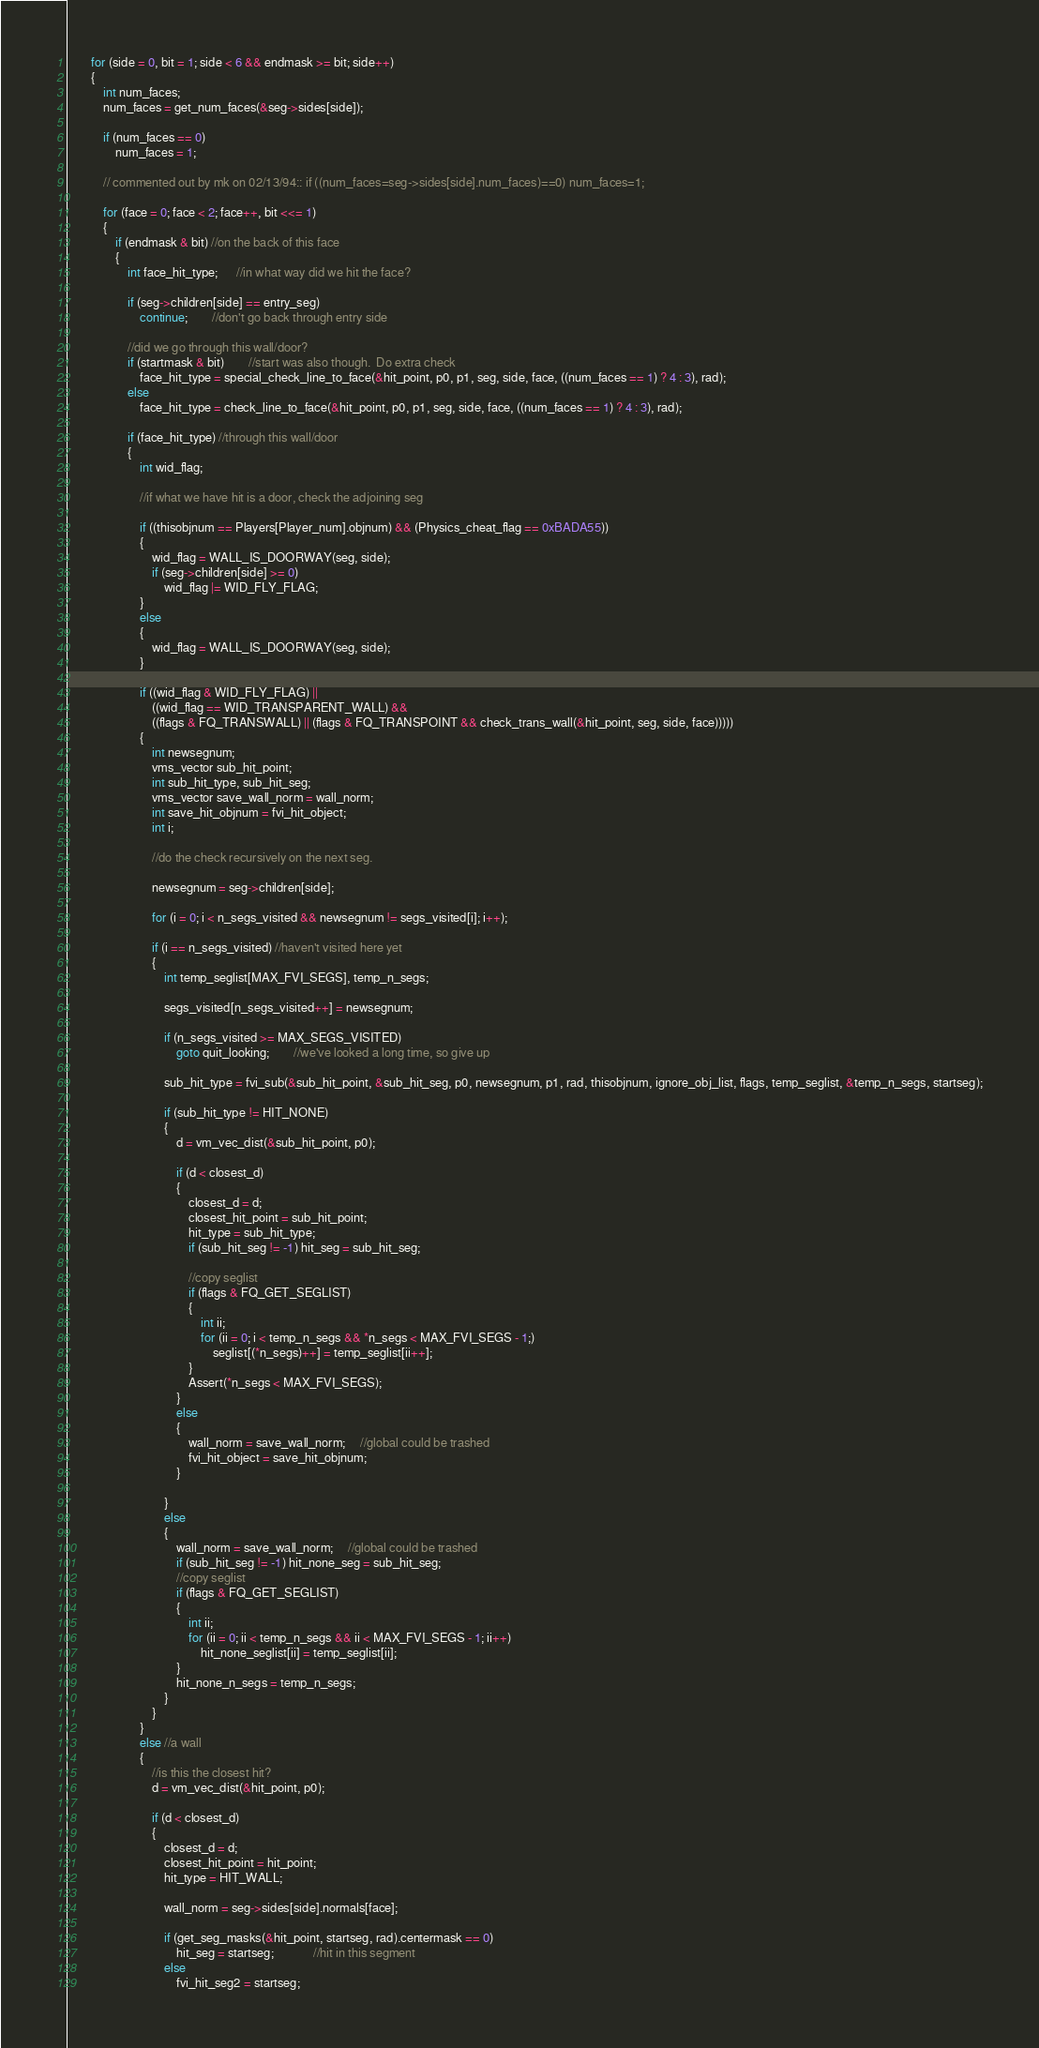<code> <loc_0><loc_0><loc_500><loc_500><_C++_>		for (side = 0, bit = 1; side < 6 && endmask >= bit; side++) 
		{
			int num_faces;
			num_faces = get_num_faces(&seg->sides[side]);

			if (num_faces == 0)
				num_faces = 1;

			// commented out by mk on 02/13/94:: if ((num_faces=seg->sides[side].num_faces)==0) num_faces=1;

			for (face = 0; face < 2; face++, bit <<= 1) 
			{
				if (endmask & bit) //on the back of this face
				{            
					int face_hit_type;      //in what way did we hit the face?

					if (seg->children[side] == entry_seg)
						continue;		//don't go back through entry side

					//did we go through this wall/door?
					if (startmask & bit)		//start was also though.  Do extra check
						face_hit_type = special_check_line_to_face(&hit_point, p0, p1, seg, side, face, ((num_faces == 1) ? 4 : 3), rad);
					else
						face_hit_type = check_line_to_face(&hit_point, p0, p1, seg, side, face, ((num_faces == 1) ? 4 : 3), rad);

					if (face_hit_type) //through this wall/door
					{
						int wid_flag;

						//if what we have hit is a door, check the adjoining seg

						if ((thisobjnum == Players[Player_num].objnum) && (Physics_cheat_flag == 0xBADA55))
						{
							wid_flag = WALL_IS_DOORWAY(seg, side);
							if (seg->children[side] >= 0)
								wid_flag |= WID_FLY_FLAG;
						}
						else 
						{
							wid_flag = WALL_IS_DOORWAY(seg, side);
						}

						if ((wid_flag & WID_FLY_FLAG) ||
							((wid_flag == WID_TRANSPARENT_WALL) &&
							((flags & FQ_TRANSWALL) || (flags & FQ_TRANSPOINT && check_trans_wall(&hit_point, seg, side, face))))) 
						{
							int newsegnum;
							vms_vector sub_hit_point;
							int sub_hit_type, sub_hit_seg;
							vms_vector save_wall_norm = wall_norm;
							int save_hit_objnum = fvi_hit_object;
							int i;

							//do the check recursively on the next seg.

							newsegnum = seg->children[side];

							for (i = 0; i < n_segs_visited && newsegnum != segs_visited[i]; i++);

							if (i == n_segs_visited) //haven't visited here yet
							{
								int temp_seglist[MAX_FVI_SEGS], temp_n_segs;

								segs_visited[n_segs_visited++] = newsegnum;

								if (n_segs_visited >= MAX_SEGS_VISITED)
									goto quit_looking;		//we've looked a long time, so give up

								sub_hit_type = fvi_sub(&sub_hit_point, &sub_hit_seg, p0, newsegnum, p1, rad, thisobjnum, ignore_obj_list, flags, temp_seglist, &temp_n_segs, startseg);

								if (sub_hit_type != HIT_NONE) 
								{
									d = vm_vec_dist(&sub_hit_point, p0);

									if (d < closest_d) 
									{
										closest_d = d;
										closest_hit_point = sub_hit_point;
										hit_type = sub_hit_type;
										if (sub_hit_seg != -1) hit_seg = sub_hit_seg;

										//copy seglist
										if (flags & FQ_GET_SEGLIST) 
										{
											int ii;
											for (ii = 0; i < temp_n_segs && *n_segs < MAX_FVI_SEGS - 1;)
												seglist[(*n_segs)++] = temp_seglist[ii++];
										}
										Assert(*n_segs < MAX_FVI_SEGS);
									}
									else 
									{
										wall_norm = save_wall_norm;     //global could be trashed
										fvi_hit_object = save_hit_objnum;
									}

								}
								else 
								{
									wall_norm = save_wall_norm;     //global could be trashed
									if (sub_hit_seg != -1) hit_none_seg = sub_hit_seg;
									//copy seglist
									if (flags & FQ_GET_SEGLIST) 
									{
										int ii;
										for (ii = 0; ii < temp_n_segs && ii < MAX_FVI_SEGS - 1; ii++)
											hit_none_seglist[ii] = temp_seglist[ii];
									}
									hit_none_n_segs = temp_n_segs;
								}
							}
						}
						else //a wall
						{
							//is this the closest hit?
							d = vm_vec_dist(&hit_point, p0);

							if (d < closest_d) 
							{
								closest_d = d;
								closest_hit_point = hit_point;
								hit_type = HIT_WALL;

								wall_norm = seg->sides[side].normals[face];

								if (get_seg_masks(&hit_point, startseg, rad).centermask == 0)
									hit_seg = startseg;             //hit in this segment
								else
									fvi_hit_seg2 = startseg;
</code> 